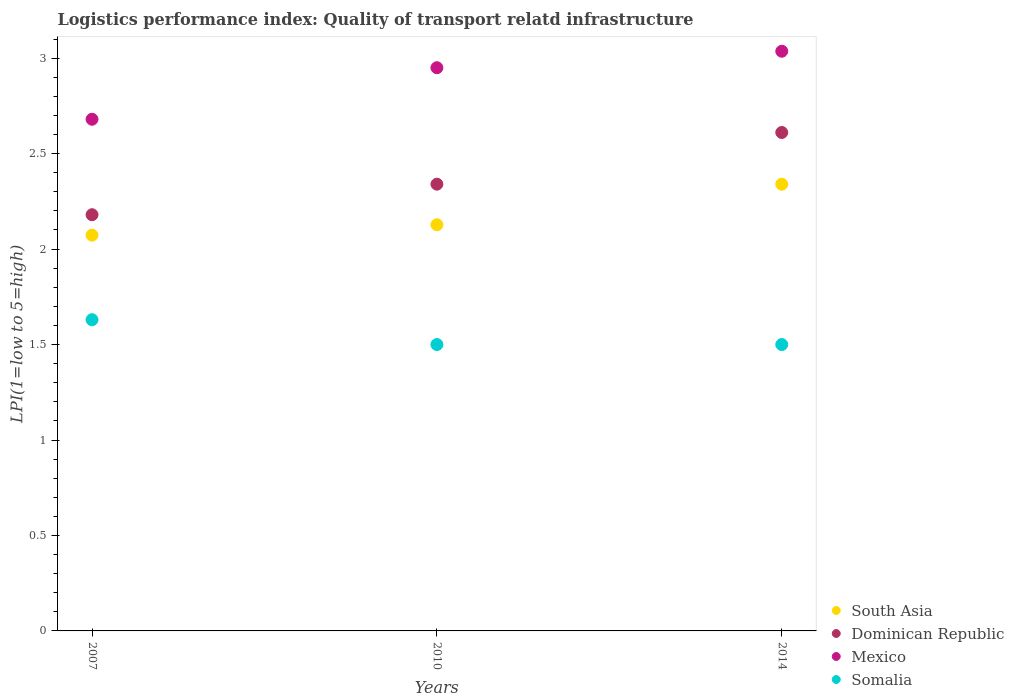How many different coloured dotlines are there?
Offer a very short reply. 4. Is the number of dotlines equal to the number of legend labels?
Offer a terse response. Yes. What is the logistics performance index in South Asia in 2014?
Offer a terse response. 2.34. Across all years, what is the maximum logistics performance index in Dominican Republic?
Provide a succinct answer. 2.61. Across all years, what is the minimum logistics performance index in Somalia?
Make the answer very short. 1.5. In which year was the logistics performance index in Somalia maximum?
Your answer should be very brief. 2007. In which year was the logistics performance index in Mexico minimum?
Provide a succinct answer. 2007. What is the total logistics performance index in Dominican Republic in the graph?
Your response must be concise. 7.13. What is the difference between the logistics performance index in South Asia in 2010 and that in 2014?
Your response must be concise. -0.21. What is the difference between the logistics performance index in Dominican Republic in 2010 and the logistics performance index in South Asia in 2007?
Offer a terse response. 0.27. What is the average logistics performance index in Mexico per year?
Offer a terse response. 2.89. In the year 2007, what is the difference between the logistics performance index in Mexico and logistics performance index in Somalia?
Your answer should be compact. 1.05. In how many years, is the logistics performance index in Mexico greater than 1.8?
Offer a very short reply. 3. What is the ratio of the logistics performance index in Dominican Republic in 2007 to that in 2010?
Ensure brevity in your answer.  0.93. What is the difference between the highest and the second highest logistics performance index in Mexico?
Give a very brief answer. 0.09. What is the difference between the highest and the lowest logistics performance index in South Asia?
Offer a very short reply. 0.27. Is it the case that in every year, the sum of the logistics performance index in Dominican Republic and logistics performance index in Somalia  is greater than the sum of logistics performance index in Mexico and logistics performance index in South Asia?
Your answer should be very brief. Yes. Is it the case that in every year, the sum of the logistics performance index in Somalia and logistics performance index in South Asia  is greater than the logistics performance index in Dominican Republic?
Ensure brevity in your answer.  Yes. Is the logistics performance index in South Asia strictly greater than the logistics performance index in Mexico over the years?
Give a very brief answer. No. Is the logistics performance index in Mexico strictly less than the logistics performance index in Somalia over the years?
Your response must be concise. No. How many years are there in the graph?
Your response must be concise. 3. Are the values on the major ticks of Y-axis written in scientific E-notation?
Your response must be concise. No. Does the graph contain grids?
Keep it short and to the point. No. How many legend labels are there?
Give a very brief answer. 4. What is the title of the graph?
Your answer should be compact. Logistics performance index: Quality of transport relatd infrastructure. Does "Georgia" appear as one of the legend labels in the graph?
Your answer should be very brief. No. What is the label or title of the Y-axis?
Provide a short and direct response. LPI(1=low to 5=high). What is the LPI(1=low to 5=high) of South Asia in 2007?
Ensure brevity in your answer.  2.07. What is the LPI(1=low to 5=high) in Dominican Republic in 2007?
Give a very brief answer. 2.18. What is the LPI(1=low to 5=high) in Mexico in 2007?
Offer a terse response. 2.68. What is the LPI(1=low to 5=high) of Somalia in 2007?
Ensure brevity in your answer.  1.63. What is the LPI(1=low to 5=high) in South Asia in 2010?
Keep it short and to the point. 2.13. What is the LPI(1=low to 5=high) of Dominican Republic in 2010?
Give a very brief answer. 2.34. What is the LPI(1=low to 5=high) of Mexico in 2010?
Provide a succinct answer. 2.95. What is the LPI(1=low to 5=high) in Somalia in 2010?
Give a very brief answer. 1.5. What is the LPI(1=low to 5=high) of South Asia in 2014?
Give a very brief answer. 2.34. What is the LPI(1=low to 5=high) of Dominican Republic in 2014?
Your answer should be compact. 2.61. What is the LPI(1=low to 5=high) of Mexico in 2014?
Your response must be concise. 3.04. Across all years, what is the maximum LPI(1=low to 5=high) of South Asia?
Give a very brief answer. 2.34. Across all years, what is the maximum LPI(1=low to 5=high) in Dominican Republic?
Offer a terse response. 2.61. Across all years, what is the maximum LPI(1=low to 5=high) of Mexico?
Your answer should be compact. 3.04. Across all years, what is the maximum LPI(1=low to 5=high) in Somalia?
Provide a succinct answer. 1.63. Across all years, what is the minimum LPI(1=low to 5=high) of South Asia?
Ensure brevity in your answer.  2.07. Across all years, what is the minimum LPI(1=low to 5=high) of Dominican Republic?
Give a very brief answer. 2.18. Across all years, what is the minimum LPI(1=low to 5=high) in Mexico?
Your answer should be very brief. 2.68. Across all years, what is the minimum LPI(1=low to 5=high) in Somalia?
Your response must be concise. 1.5. What is the total LPI(1=low to 5=high) in South Asia in the graph?
Provide a short and direct response. 6.54. What is the total LPI(1=low to 5=high) of Dominican Republic in the graph?
Make the answer very short. 7.13. What is the total LPI(1=low to 5=high) in Mexico in the graph?
Make the answer very short. 8.67. What is the total LPI(1=low to 5=high) in Somalia in the graph?
Keep it short and to the point. 4.63. What is the difference between the LPI(1=low to 5=high) of South Asia in 2007 and that in 2010?
Provide a short and direct response. -0.05. What is the difference between the LPI(1=low to 5=high) in Dominican Republic in 2007 and that in 2010?
Your answer should be very brief. -0.16. What is the difference between the LPI(1=low to 5=high) in Mexico in 2007 and that in 2010?
Keep it short and to the point. -0.27. What is the difference between the LPI(1=low to 5=high) in Somalia in 2007 and that in 2010?
Offer a terse response. 0.13. What is the difference between the LPI(1=low to 5=high) of South Asia in 2007 and that in 2014?
Give a very brief answer. -0.27. What is the difference between the LPI(1=low to 5=high) of Dominican Republic in 2007 and that in 2014?
Your response must be concise. -0.43. What is the difference between the LPI(1=low to 5=high) of Mexico in 2007 and that in 2014?
Make the answer very short. -0.36. What is the difference between the LPI(1=low to 5=high) of Somalia in 2007 and that in 2014?
Give a very brief answer. 0.13. What is the difference between the LPI(1=low to 5=high) of South Asia in 2010 and that in 2014?
Provide a short and direct response. -0.21. What is the difference between the LPI(1=low to 5=high) of Dominican Republic in 2010 and that in 2014?
Your response must be concise. -0.27. What is the difference between the LPI(1=low to 5=high) in Mexico in 2010 and that in 2014?
Offer a very short reply. -0.09. What is the difference between the LPI(1=low to 5=high) of Somalia in 2010 and that in 2014?
Provide a short and direct response. 0. What is the difference between the LPI(1=low to 5=high) of South Asia in 2007 and the LPI(1=low to 5=high) of Dominican Republic in 2010?
Your answer should be compact. -0.27. What is the difference between the LPI(1=low to 5=high) in South Asia in 2007 and the LPI(1=low to 5=high) in Mexico in 2010?
Provide a short and direct response. -0.88. What is the difference between the LPI(1=low to 5=high) of South Asia in 2007 and the LPI(1=low to 5=high) of Somalia in 2010?
Provide a succinct answer. 0.57. What is the difference between the LPI(1=low to 5=high) in Dominican Republic in 2007 and the LPI(1=low to 5=high) in Mexico in 2010?
Your answer should be compact. -0.77. What is the difference between the LPI(1=low to 5=high) of Dominican Republic in 2007 and the LPI(1=low to 5=high) of Somalia in 2010?
Offer a terse response. 0.68. What is the difference between the LPI(1=low to 5=high) in Mexico in 2007 and the LPI(1=low to 5=high) in Somalia in 2010?
Provide a succinct answer. 1.18. What is the difference between the LPI(1=low to 5=high) of South Asia in 2007 and the LPI(1=low to 5=high) of Dominican Republic in 2014?
Ensure brevity in your answer.  -0.54. What is the difference between the LPI(1=low to 5=high) in South Asia in 2007 and the LPI(1=low to 5=high) in Mexico in 2014?
Keep it short and to the point. -0.96. What is the difference between the LPI(1=low to 5=high) in South Asia in 2007 and the LPI(1=low to 5=high) in Somalia in 2014?
Offer a very short reply. 0.57. What is the difference between the LPI(1=low to 5=high) in Dominican Republic in 2007 and the LPI(1=low to 5=high) in Mexico in 2014?
Your response must be concise. -0.86. What is the difference between the LPI(1=low to 5=high) of Dominican Republic in 2007 and the LPI(1=low to 5=high) of Somalia in 2014?
Your answer should be very brief. 0.68. What is the difference between the LPI(1=low to 5=high) in Mexico in 2007 and the LPI(1=low to 5=high) in Somalia in 2014?
Your answer should be very brief. 1.18. What is the difference between the LPI(1=low to 5=high) in South Asia in 2010 and the LPI(1=low to 5=high) in Dominican Republic in 2014?
Your answer should be compact. -0.48. What is the difference between the LPI(1=low to 5=high) in South Asia in 2010 and the LPI(1=low to 5=high) in Mexico in 2014?
Keep it short and to the point. -0.91. What is the difference between the LPI(1=low to 5=high) of South Asia in 2010 and the LPI(1=low to 5=high) of Somalia in 2014?
Offer a very short reply. 0.63. What is the difference between the LPI(1=low to 5=high) in Dominican Republic in 2010 and the LPI(1=low to 5=high) in Mexico in 2014?
Offer a terse response. -0.7. What is the difference between the LPI(1=low to 5=high) in Dominican Republic in 2010 and the LPI(1=low to 5=high) in Somalia in 2014?
Offer a terse response. 0.84. What is the difference between the LPI(1=low to 5=high) of Mexico in 2010 and the LPI(1=low to 5=high) of Somalia in 2014?
Your response must be concise. 1.45. What is the average LPI(1=low to 5=high) in South Asia per year?
Offer a terse response. 2.18. What is the average LPI(1=low to 5=high) in Dominican Republic per year?
Make the answer very short. 2.38. What is the average LPI(1=low to 5=high) of Mexico per year?
Keep it short and to the point. 2.89. What is the average LPI(1=low to 5=high) of Somalia per year?
Offer a terse response. 1.54. In the year 2007, what is the difference between the LPI(1=low to 5=high) of South Asia and LPI(1=low to 5=high) of Dominican Republic?
Your answer should be very brief. -0.11. In the year 2007, what is the difference between the LPI(1=low to 5=high) in South Asia and LPI(1=low to 5=high) in Mexico?
Offer a very short reply. -0.61. In the year 2007, what is the difference between the LPI(1=low to 5=high) in South Asia and LPI(1=low to 5=high) in Somalia?
Offer a very short reply. 0.44. In the year 2007, what is the difference between the LPI(1=low to 5=high) of Dominican Republic and LPI(1=low to 5=high) of Somalia?
Offer a very short reply. 0.55. In the year 2010, what is the difference between the LPI(1=low to 5=high) of South Asia and LPI(1=low to 5=high) of Dominican Republic?
Give a very brief answer. -0.21. In the year 2010, what is the difference between the LPI(1=low to 5=high) of South Asia and LPI(1=low to 5=high) of Mexico?
Give a very brief answer. -0.82. In the year 2010, what is the difference between the LPI(1=low to 5=high) in South Asia and LPI(1=low to 5=high) in Somalia?
Your answer should be very brief. 0.63. In the year 2010, what is the difference between the LPI(1=low to 5=high) in Dominican Republic and LPI(1=low to 5=high) in Mexico?
Keep it short and to the point. -0.61. In the year 2010, what is the difference between the LPI(1=low to 5=high) in Dominican Republic and LPI(1=low to 5=high) in Somalia?
Provide a short and direct response. 0.84. In the year 2010, what is the difference between the LPI(1=low to 5=high) of Mexico and LPI(1=low to 5=high) of Somalia?
Offer a very short reply. 1.45. In the year 2014, what is the difference between the LPI(1=low to 5=high) in South Asia and LPI(1=low to 5=high) in Dominican Republic?
Make the answer very short. -0.27. In the year 2014, what is the difference between the LPI(1=low to 5=high) of South Asia and LPI(1=low to 5=high) of Mexico?
Your answer should be very brief. -0.7. In the year 2014, what is the difference between the LPI(1=low to 5=high) of South Asia and LPI(1=low to 5=high) of Somalia?
Your response must be concise. 0.84. In the year 2014, what is the difference between the LPI(1=low to 5=high) of Dominican Republic and LPI(1=low to 5=high) of Mexico?
Offer a terse response. -0.43. In the year 2014, what is the difference between the LPI(1=low to 5=high) in Dominican Republic and LPI(1=low to 5=high) in Somalia?
Give a very brief answer. 1.11. In the year 2014, what is the difference between the LPI(1=low to 5=high) of Mexico and LPI(1=low to 5=high) of Somalia?
Ensure brevity in your answer.  1.54. What is the ratio of the LPI(1=low to 5=high) of South Asia in 2007 to that in 2010?
Give a very brief answer. 0.97. What is the ratio of the LPI(1=low to 5=high) in Dominican Republic in 2007 to that in 2010?
Offer a terse response. 0.93. What is the ratio of the LPI(1=low to 5=high) in Mexico in 2007 to that in 2010?
Give a very brief answer. 0.91. What is the ratio of the LPI(1=low to 5=high) of Somalia in 2007 to that in 2010?
Keep it short and to the point. 1.09. What is the ratio of the LPI(1=low to 5=high) of South Asia in 2007 to that in 2014?
Offer a terse response. 0.89. What is the ratio of the LPI(1=low to 5=high) of Dominican Republic in 2007 to that in 2014?
Keep it short and to the point. 0.83. What is the ratio of the LPI(1=low to 5=high) of Mexico in 2007 to that in 2014?
Offer a very short reply. 0.88. What is the ratio of the LPI(1=low to 5=high) in Somalia in 2007 to that in 2014?
Provide a succinct answer. 1.09. What is the ratio of the LPI(1=low to 5=high) of South Asia in 2010 to that in 2014?
Offer a terse response. 0.91. What is the ratio of the LPI(1=low to 5=high) of Dominican Republic in 2010 to that in 2014?
Provide a short and direct response. 0.9. What is the ratio of the LPI(1=low to 5=high) of Mexico in 2010 to that in 2014?
Keep it short and to the point. 0.97. What is the difference between the highest and the second highest LPI(1=low to 5=high) of South Asia?
Ensure brevity in your answer.  0.21. What is the difference between the highest and the second highest LPI(1=low to 5=high) of Dominican Republic?
Offer a terse response. 0.27. What is the difference between the highest and the second highest LPI(1=low to 5=high) of Mexico?
Provide a succinct answer. 0.09. What is the difference between the highest and the second highest LPI(1=low to 5=high) of Somalia?
Your answer should be very brief. 0.13. What is the difference between the highest and the lowest LPI(1=low to 5=high) of South Asia?
Keep it short and to the point. 0.27. What is the difference between the highest and the lowest LPI(1=low to 5=high) in Dominican Republic?
Provide a short and direct response. 0.43. What is the difference between the highest and the lowest LPI(1=low to 5=high) in Mexico?
Your answer should be very brief. 0.36. What is the difference between the highest and the lowest LPI(1=low to 5=high) of Somalia?
Your answer should be compact. 0.13. 